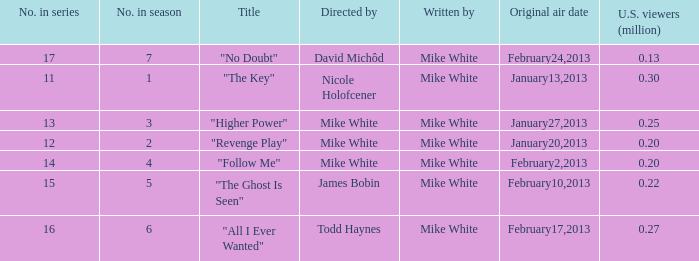How many episodes in the serie were title "the key" 1.0. 